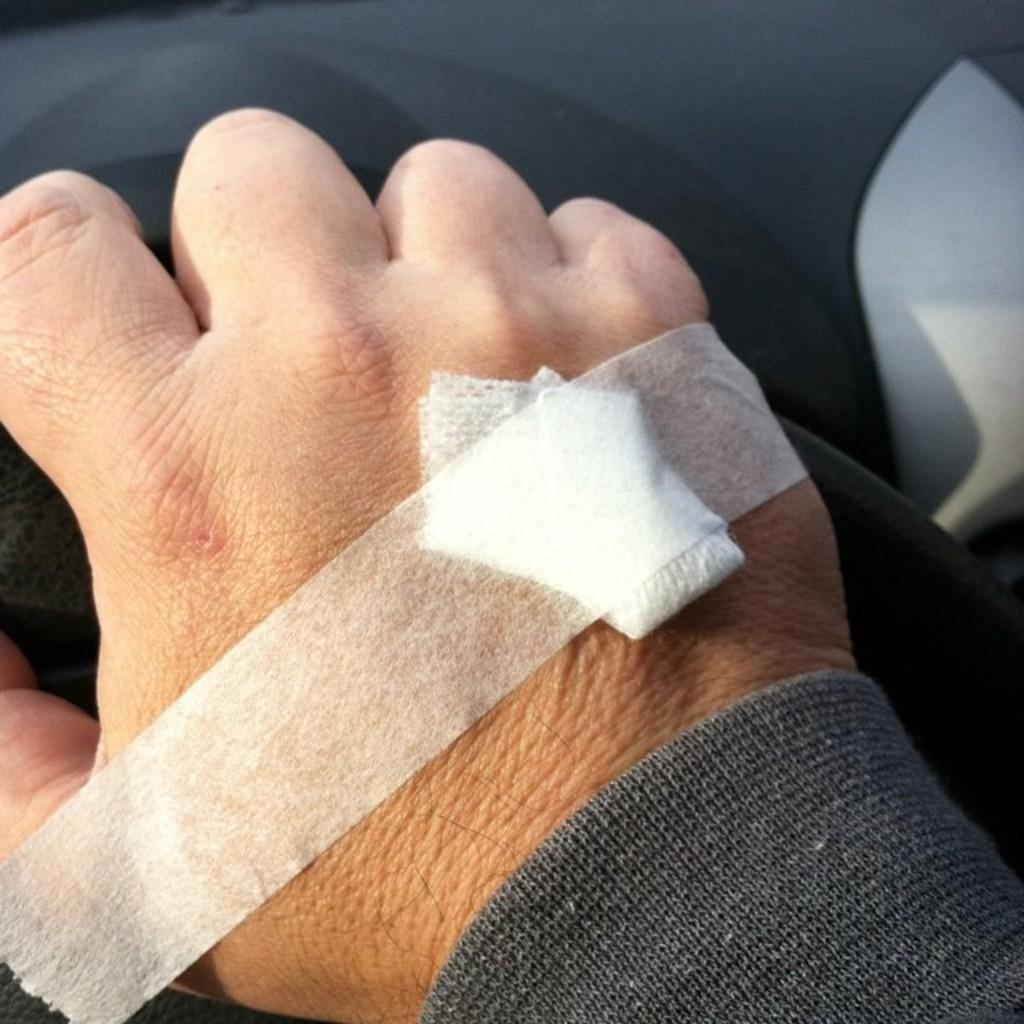What is the main subject of the image? The main subject of the image is a person's hand. Can you describe the condition of the hand in the image? The hand has a bandage on it. Where is the hand located in the image? The hand is in the center of the image. What type of stocking is visible on the hand in the image? There is no stocking present on the hand in the image; it has a bandage instead. What kind of seed can be seen growing on the hand in the image? There is no seed growing on the hand in the image; it has a bandage instead. 